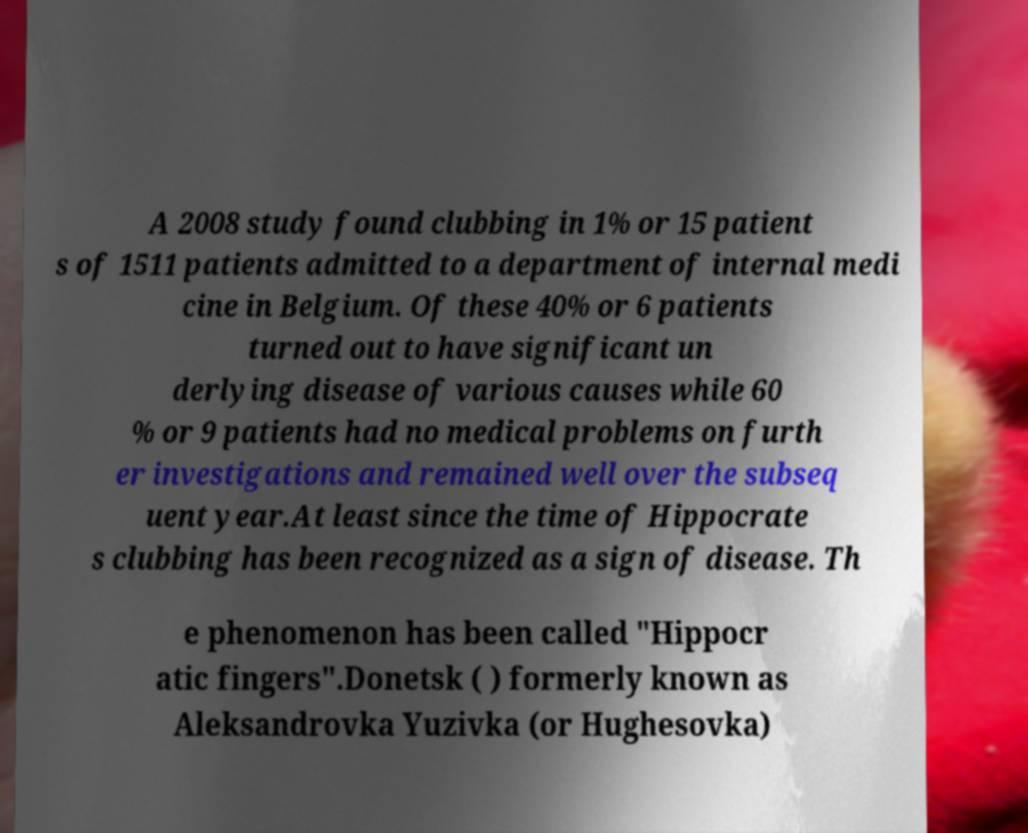Could you assist in decoding the text presented in this image and type it out clearly? A 2008 study found clubbing in 1% or 15 patient s of 1511 patients admitted to a department of internal medi cine in Belgium. Of these 40% or 6 patients turned out to have significant un derlying disease of various causes while 60 % or 9 patients had no medical problems on furth er investigations and remained well over the subseq uent year.At least since the time of Hippocrate s clubbing has been recognized as a sign of disease. Th e phenomenon has been called "Hippocr atic fingers".Donetsk ( ) formerly known as Aleksandrovka Yuzivka (or Hughesovka) 